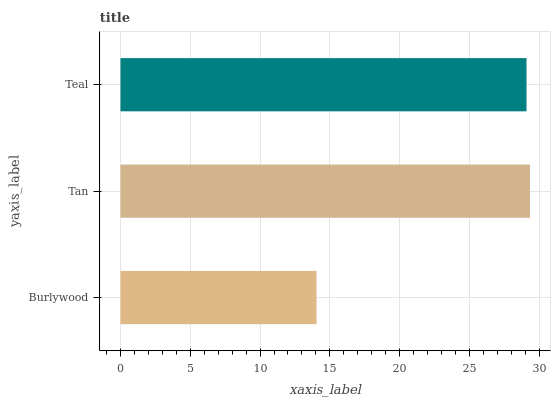Is Burlywood the minimum?
Answer yes or no. Yes. Is Tan the maximum?
Answer yes or no. Yes. Is Teal the minimum?
Answer yes or no. No. Is Teal the maximum?
Answer yes or no. No. Is Tan greater than Teal?
Answer yes or no. Yes. Is Teal less than Tan?
Answer yes or no. Yes. Is Teal greater than Tan?
Answer yes or no. No. Is Tan less than Teal?
Answer yes or no. No. Is Teal the high median?
Answer yes or no. Yes. Is Teal the low median?
Answer yes or no. Yes. Is Tan the high median?
Answer yes or no. No. Is Tan the low median?
Answer yes or no. No. 